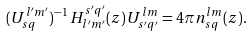Convert formula to latex. <formula><loc_0><loc_0><loc_500><loc_500>( U _ { s q } ^ { l ^ { \prime } m ^ { \prime } } ) ^ { - 1 } \, H _ { l ^ { \prime } m ^ { \prime } } ^ { s ^ { \prime } q ^ { \prime } } ( z ) \, U _ { s ^ { \prime } q ^ { \prime } } ^ { l m } = 4 \pi n _ { s q } ^ { l m } ( z ) .</formula> 